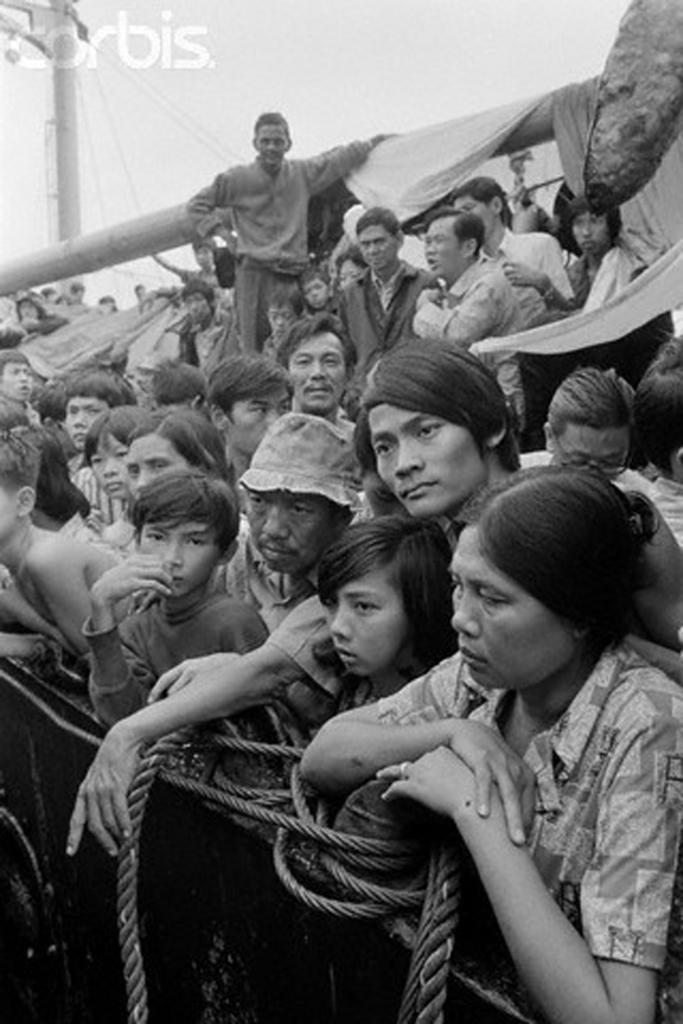How many people are in the image? There is a group of people in the image, but the exact number cannot be determined from the provided facts. What are the people in the image doing? Some people are sitting, while others are standing. What objects can be seen in the image besides the people? There are ropes visible in the image, and there is a light pole in the background. What is the color scheme of the image? The image is in black and white. What type of game is being played by the people in the image? There is no indication of a game being played in the image; it only shows a group of people with some sitting and others standing. Is there a van visible in the image? No, there is no van present in the image. 